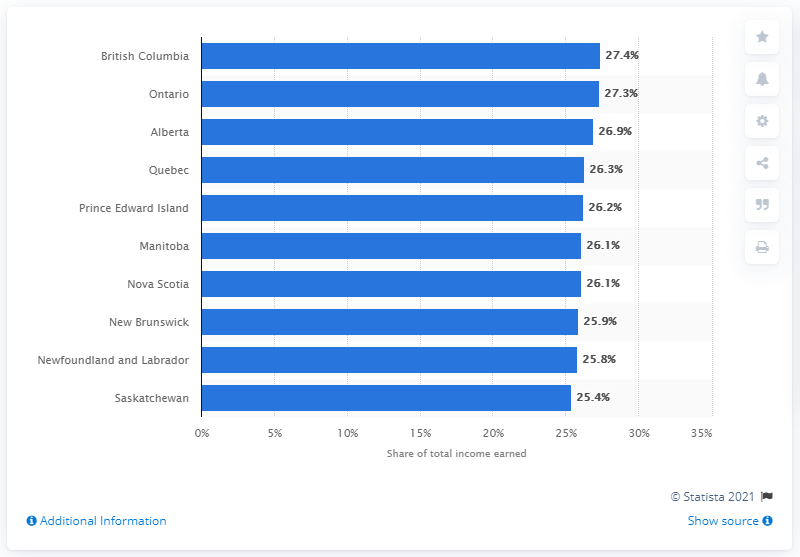Mention a couple of crucial points in this snapshot. In 2018, the highest income decile in Alberta earned 26.9% of all after-tax income in the province. 